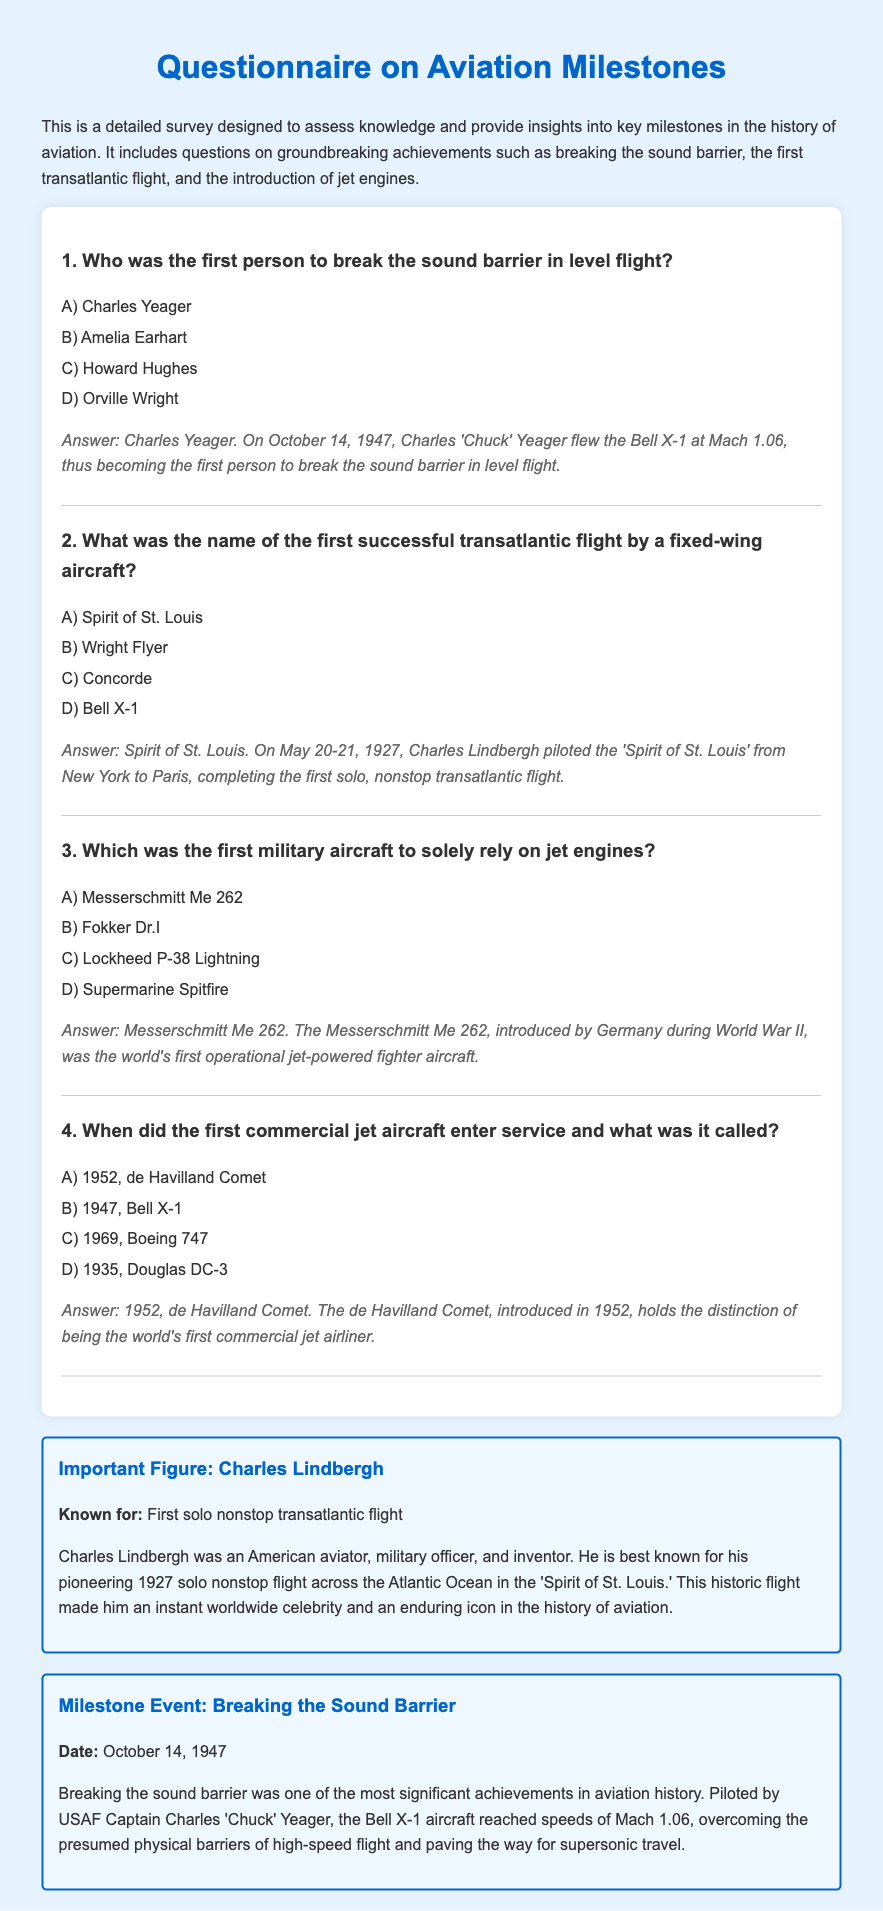Who was the first person to break the sound barrier in level flight? The document states that the first person to break the sound barrier in level flight was Charles Yeager, who did so on October 14, 1947.
Answer: Charles Yeager What was the name of the first successful transatlantic flight by a fixed-wing aircraft? According to the document, the first successful transatlantic flight by a fixed-wing aircraft was made by Charles Lindbergh in the 'Spirit of St. Louis'.
Answer: Spirit of St. Louis Which was the first military aircraft to solely rely on jet engines? The document informs that the first military aircraft to solely rely on jet engines was the Messerschmitt Me 262.
Answer: Messerschmitt Me 262 When did the first commercial jet aircraft enter service and what was it called? The first commercial jet aircraft, the de Havilland Comet, entered service in 1952 according to the document.
Answer: 1952, de Havilland Comet What date did Charles Yeager break the sound barrier? The document specifies that Charles Yeager broke the sound barrier on October 14, 1947.
Answer: October 14, 1947 What achievement is Charles Lindbergh best known for? The document states that Charles Lindbergh is best known for his pioneering 1927 solo nonstop flight across the Atlantic Ocean in the 'Spirit of St. Louis'.
Answer: First solo nonstop transatlantic flight What speed did the Bell X-1 reach when it broke the sound barrier? The document mentions that the Bell X-1 reached speeds of Mach 1.06 when it broke the sound barrier.
Answer: Mach 1.06 Who is known for the introduction of the first operational jet-powered fighter aircraft? The document attributes the introduction of the first operational jet-powered fighter aircraft, the Messerschmitt Me 262, to Germany during World War II.
Answer: Germany What year was the de Havilland Comet introduced? According to the document, the de Havilland Comet was introduced in 1952.
Answer: 1952 